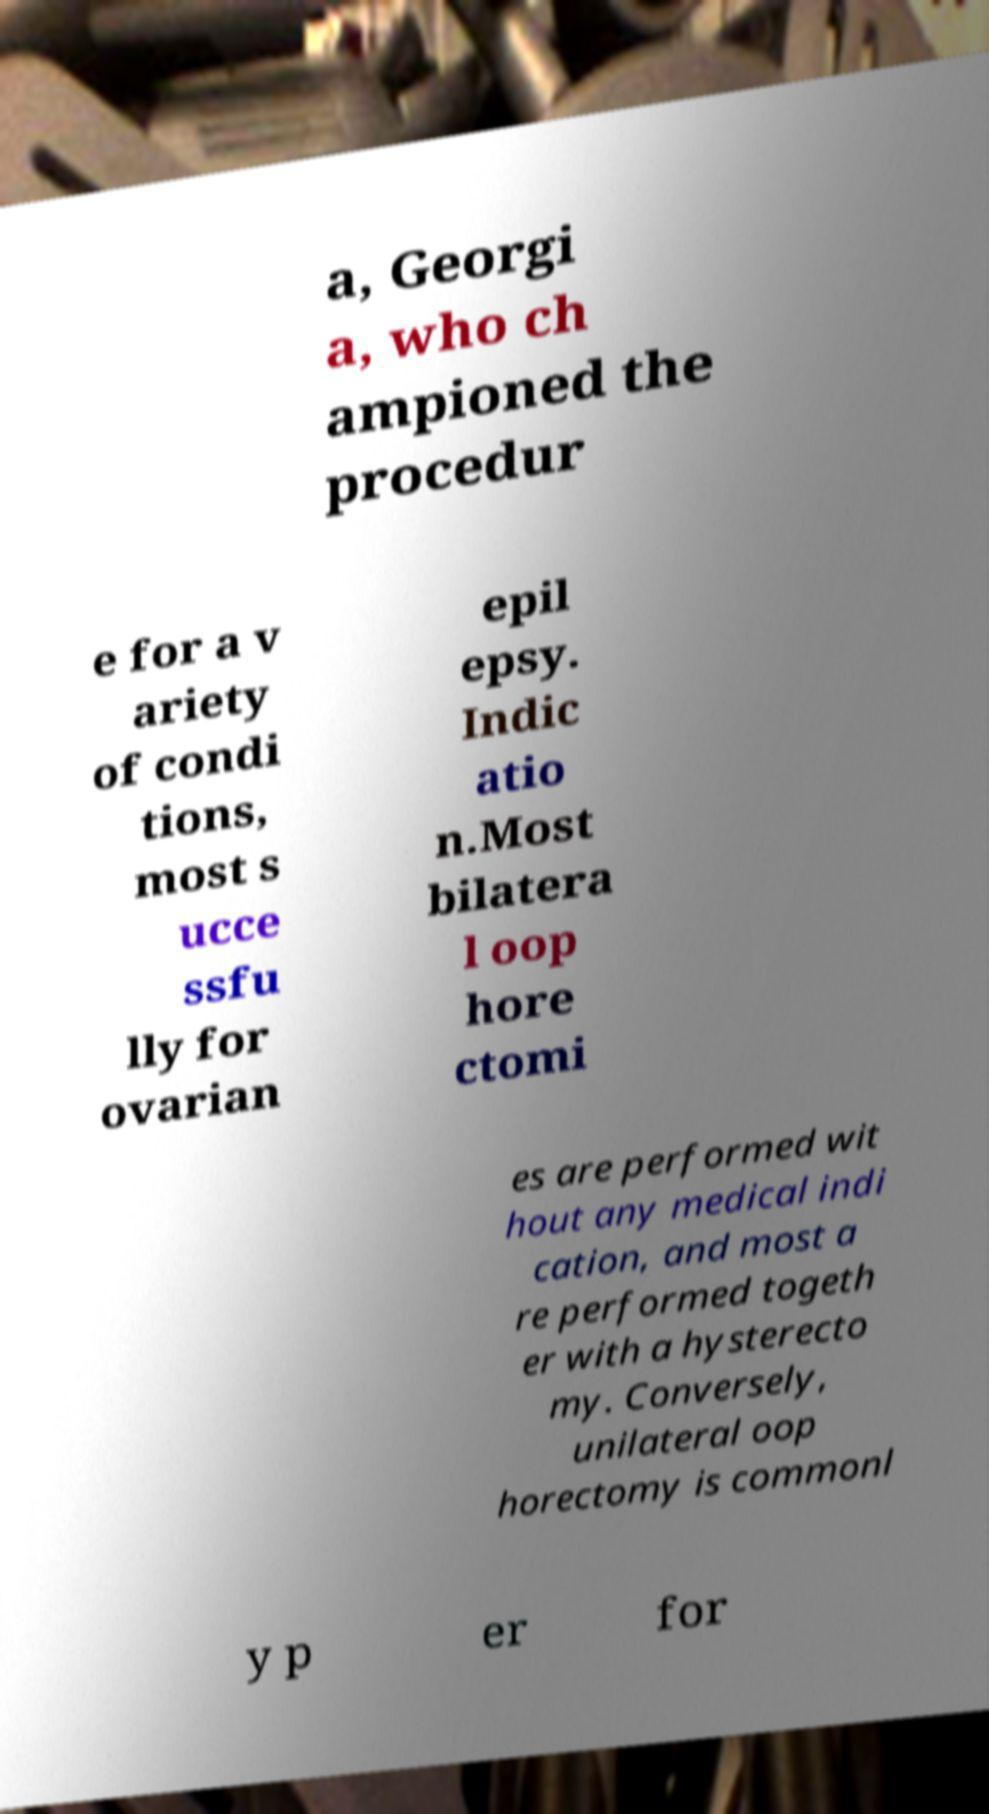Can you accurately transcribe the text from the provided image for me? a, Georgi a, who ch ampioned the procedur e for a v ariety of condi tions, most s ucce ssfu lly for ovarian epil epsy. Indic atio n.Most bilatera l oop hore ctomi es are performed wit hout any medical indi cation, and most a re performed togeth er with a hysterecto my. Conversely, unilateral oop horectomy is commonl y p er for 